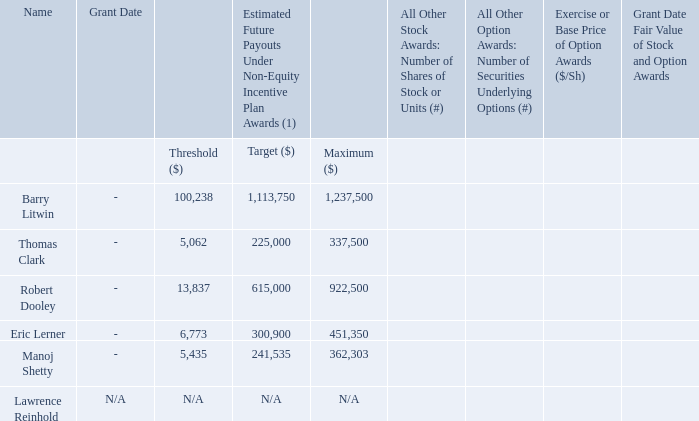Grants of Plan-Based Awards
The following table sets forth the estimated possible payouts under the cash incentive awards granted to our Named
Executive Officers in respect of 2019 performance under the 2019 NEO Plan.
(1) Amounts presented assume payment of threshold, target and maximum awards at the applicable level.
What is the maximum estimated future payouts under the 2019 NEO plan for Barry Litwin and Thomas Clark? 1,237,500, 337,500. What is the maximum estimated future payouts under the 2019 NEO plan for Robert Dooley and Eric Lerner? 922,500, 451,350. What is the maximum estimated future payouts under the 2019 NEO plan for Manoj Shetty and Lawrence Reinhold? 362,303, n/a. What is the difference between Manoj Shetty's estimated maximum and target payouts in the future under the 2019 NEO Plan? 362,303 - 241,535 
Answer: 120768. What is Eric Lerner's threshold estimated future payouts under the 2019 NEO plan as a percentage of Thomas Clark's threshold payouts?
Answer scale should be: percent. 6,773/5,062 
Answer: 133.8. What is the total target payout under the 2019 NEO Plan for the highest and lowest paying Named Executive Officer under the 2019 NEO Plan? 1,113,750 + 225,000 
Answer: 1338750. 